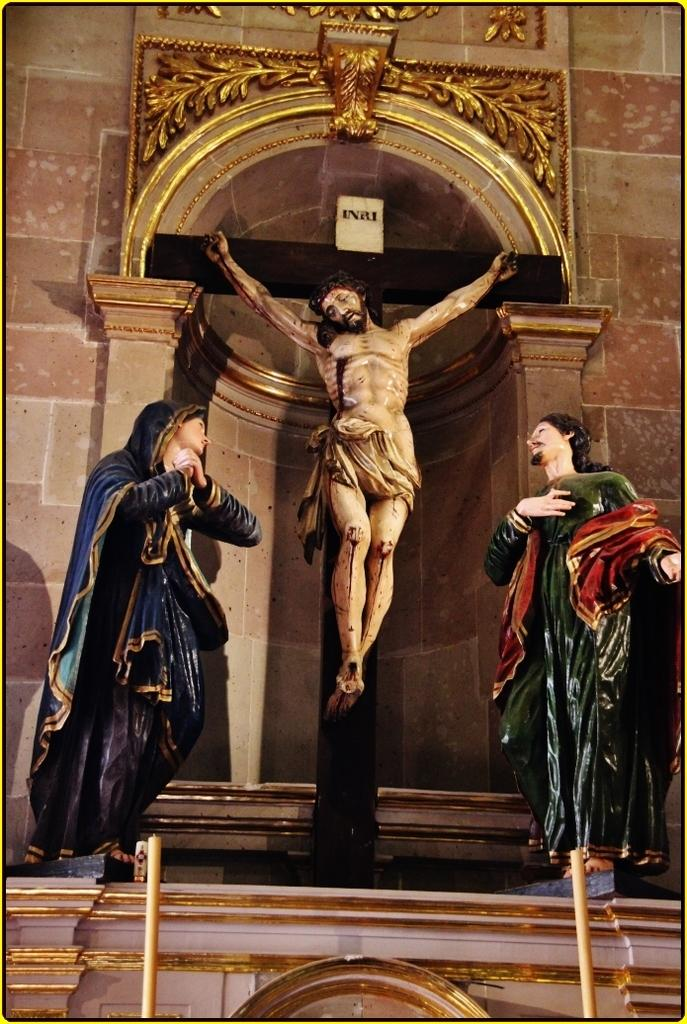What type of objects can be seen in the image? There are sculptures, pillars, and an arch in the image. Can you describe the architectural elements in the image? The image features pillars and an arch. What artistic elements are present in the image? The sculptures in the image are artistic elements. Can you see any arguments taking place in the image? There are no arguments visible in the image; it features sculptures, pillars, and an arch. How many eyes can be seen on the sculptures in the image? There is no mention of eyes on the sculptures in the image, as the facts provided do not include any details about the sculptures' features. 